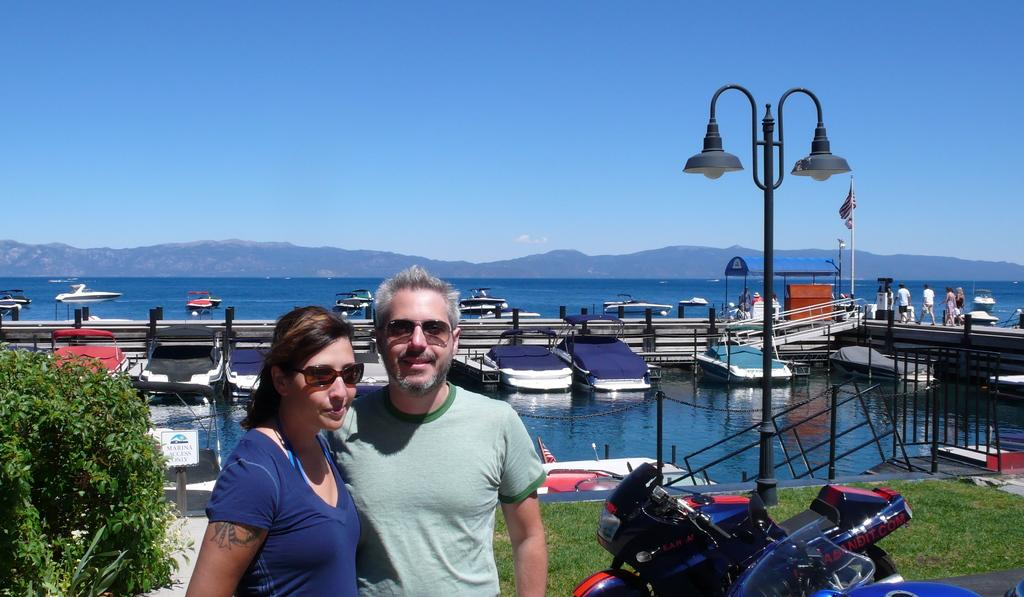How many people are present in the image? There are people in the image, but the exact number cannot be determined from the provided facts. What structure can be seen in the image? There is a light pole, rods, chains, a grille, an information board, and an open-shed in the image. What type of vegetation is present in the image? There is grass and a plant in the image. What mode of transportation is visible in the image? There are motorbikes in the image. What type of water body is visible in the image? There are boats in the image, which suggests the presence of a water body, but the exact type cannot be determined from the provided facts. What architectural feature is present in the image? There is an open-shed in the image. What is the color of the sky in the image? The sky is blue in the image. What geographical feature is present in the image? There are hills in the image. Where is the beetle flying in the image? There is no beetle present in the image. What type of kite is being flown in the image? There is no kite present in the image. What type of seashore can be seen in the image? There is no seashore present in the image. 